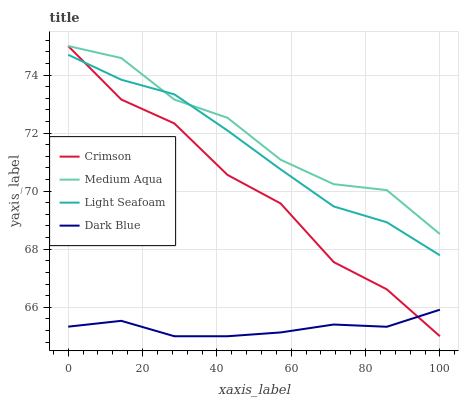Does Dark Blue have the minimum area under the curve?
Answer yes or no. Yes. Does Medium Aqua have the maximum area under the curve?
Answer yes or no. Yes. Does Light Seafoam have the minimum area under the curve?
Answer yes or no. No. Does Light Seafoam have the maximum area under the curve?
Answer yes or no. No. Is Dark Blue the smoothest?
Answer yes or no. Yes. Is Crimson the roughest?
Answer yes or no. Yes. Is Light Seafoam the smoothest?
Answer yes or no. No. Is Light Seafoam the roughest?
Answer yes or no. No. Does Light Seafoam have the lowest value?
Answer yes or no. No. Does Medium Aqua have the highest value?
Answer yes or no. Yes. Does Light Seafoam have the highest value?
Answer yes or no. No. Is Dark Blue less than Light Seafoam?
Answer yes or no. Yes. Is Medium Aqua greater than Dark Blue?
Answer yes or no. Yes. Does Dark Blue intersect Light Seafoam?
Answer yes or no. No. 